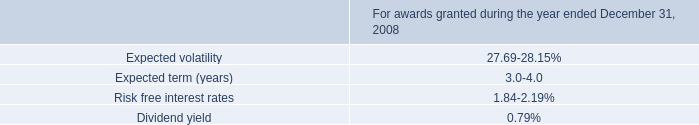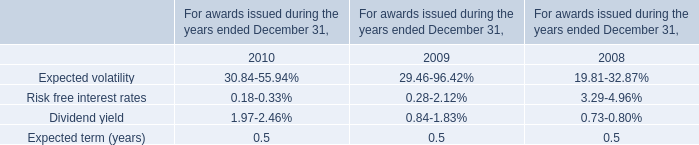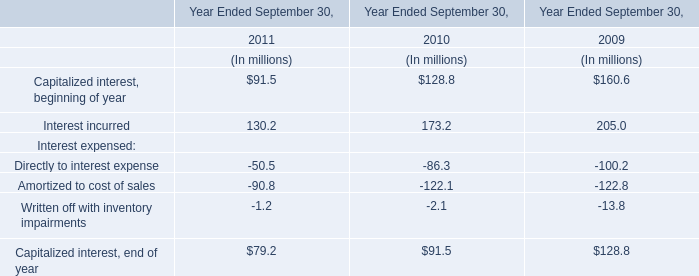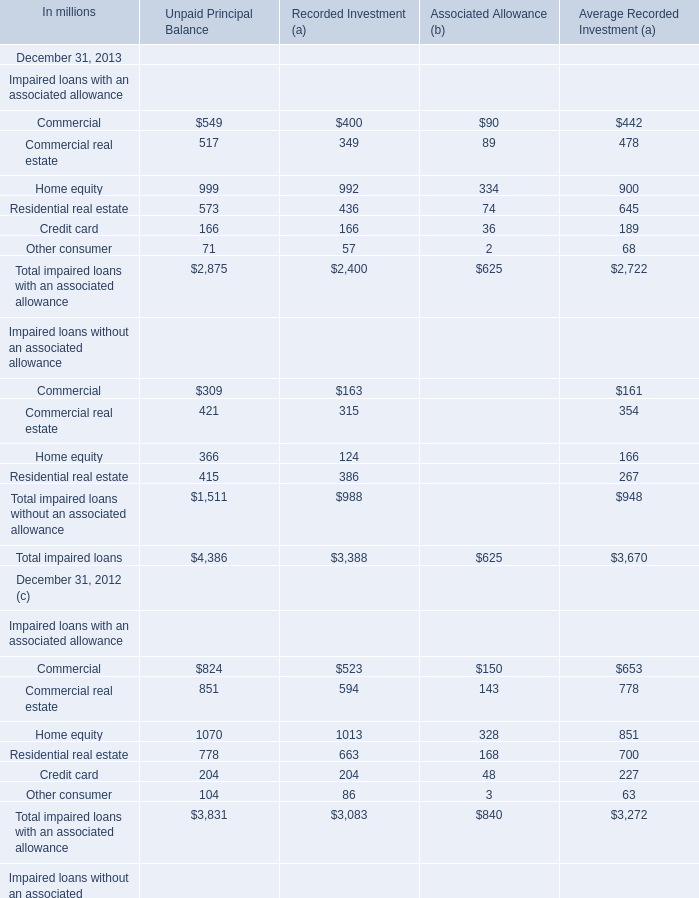What was the total amount of Impaired loans with an associated allowance greater than 500 in 2013 for unpaid principal balance? (in million) 
Computations: (((549 + 517) + 999) + 573)
Answer: 2638.0. 